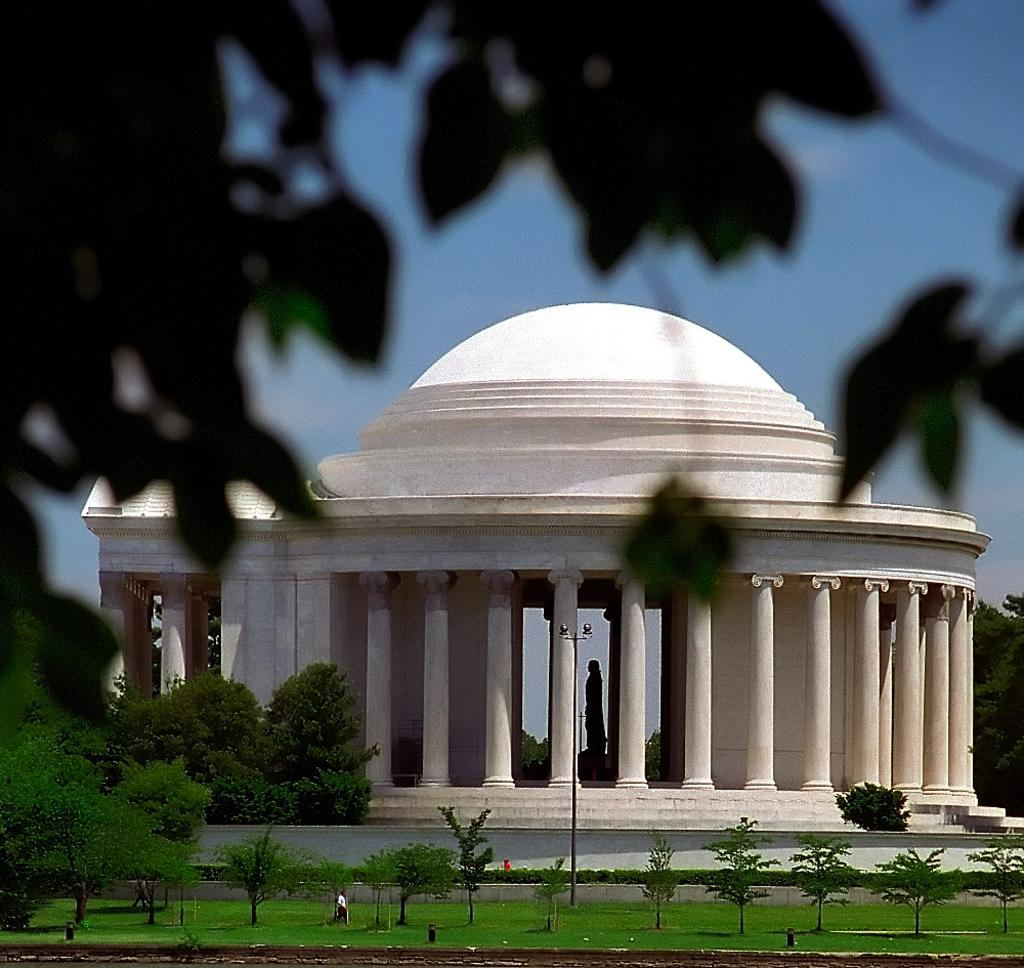What type of vegetation can be seen in the image? There are trees, grass, and plants in the image. What type of structure is present in the image? There is a white building in the image. What architectural feature is prominent on the white building? The white building has many white pillars. What is visible at the top of the image? The sky is visible at the top of the image. What type of can is visible in the image? There is no can present in the image. What scent can be detected from the plants in the image? The image does not provide information about the scent of the plants, so it cannot be determined from the image. 